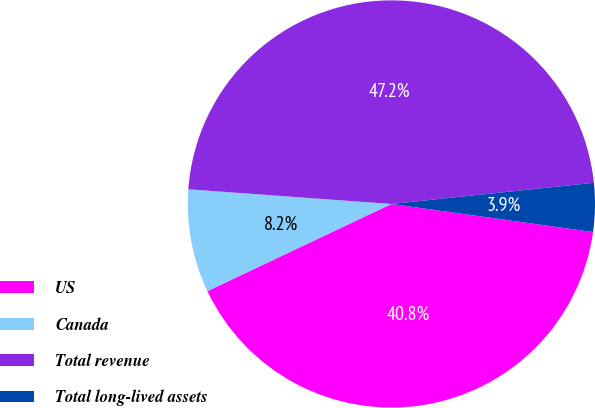Convert chart to OTSL. <chart><loc_0><loc_0><loc_500><loc_500><pie_chart><fcel>US<fcel>Canada<fcel>Total revenue<fcel>Total long-lived assets<nl><fcel>40.75%<fcel>8.19%<fcel>47.19%<fcel>3.86%<nl></chart> 